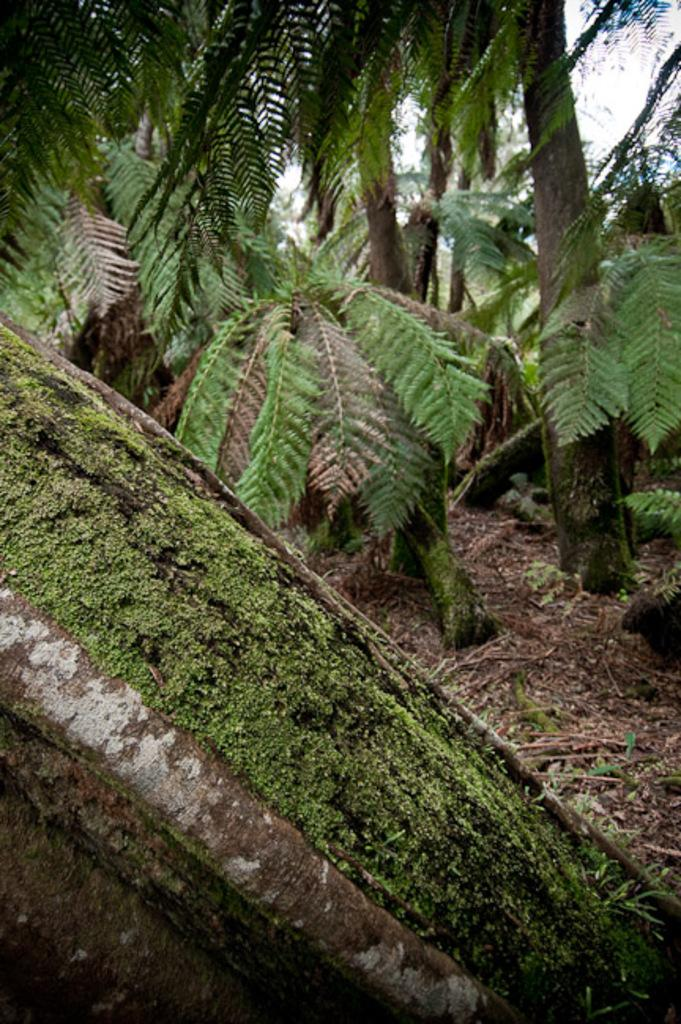What is located at the bottom of the image? There is a stem of a tree at the bottom of the image. What else can be seen in the image besides the tree stem? There are other trees visible in the background of the image. What type of collar can be seen on the tree in the image? There is no collar present on the tree in the image. 